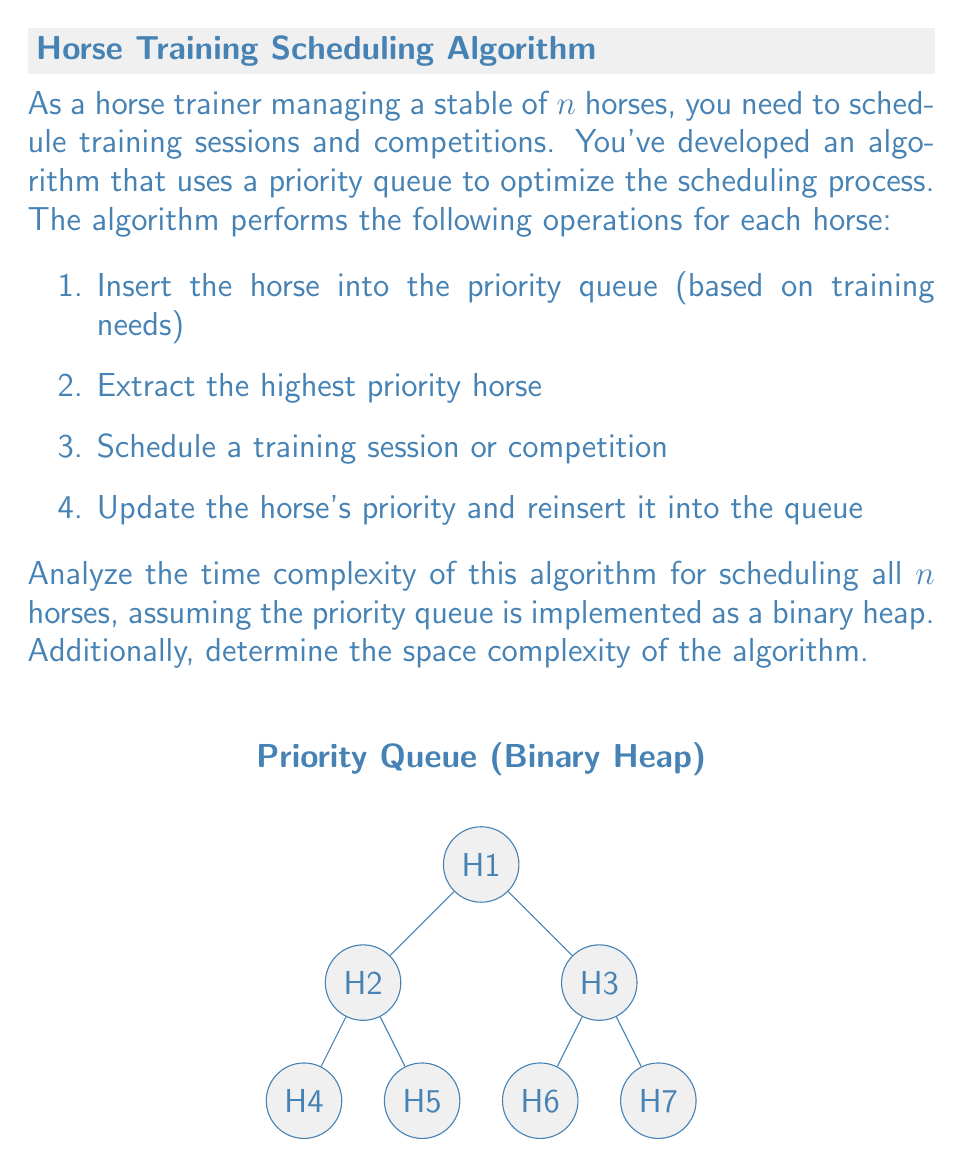Can you solve this math problem? Let's analyze the time and space complexity of this algorithm step by step:

1. Time Complexity:
   a. Insertion into a binary heap: $O(\log n)$
   b. Extraction of highest priority element: $O(\log n)$
   c. Scheduling (assuming constant time): $O(1)$
   d. Updating priority and reinsertion: $O(\log n)$

   For each horse, we perform these operations once. So, the time complexity for one horse is:
   $O(\log n) + O(\log n) + O(1) + O(\log n) = O(\log n)$

   Since we have $n$ horses, the total time complexity is:
   $n \cdot O(\log n) = O(n \log n)$

2. Space Complexity:
   The main data structure used is the priority queue (binary heap), which stores all $n$ horses at once.
   The space required for a binary heap is $O(n)$.

   Additional space for variables and the scheduling process is constant, so it doesn't affect the overall space complexity.

Therefore, the space complexity is $O(n)$.
Answer: Time complexity: $O(n \log n)$, Space complexity: $O(n)$ 